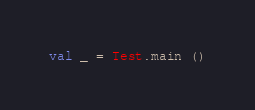Convert code to text. <code><loc_0><loc_0><loc_500><loc_500><_SML_>val _ = Test.main ()
</code> 